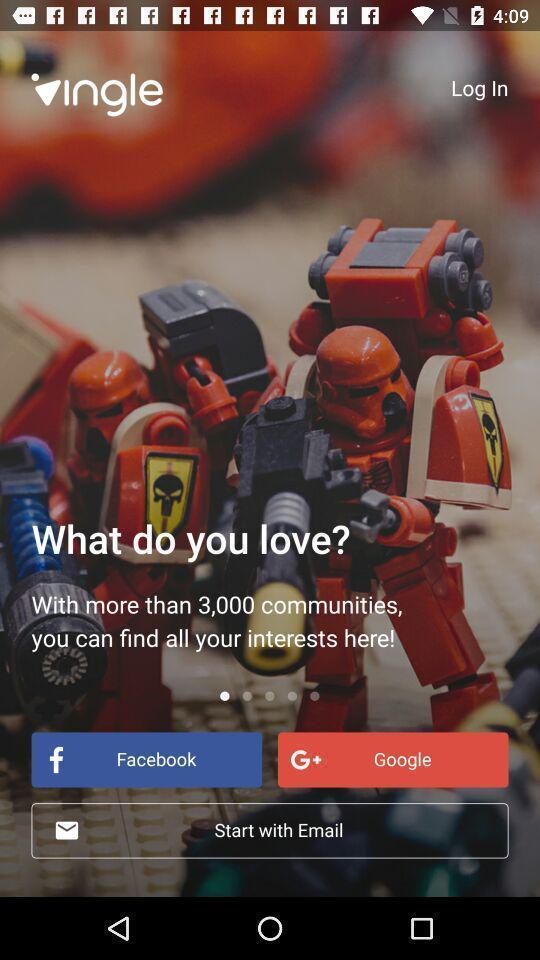Summarize the information in this screenshot. Starting page of the game application with question. 